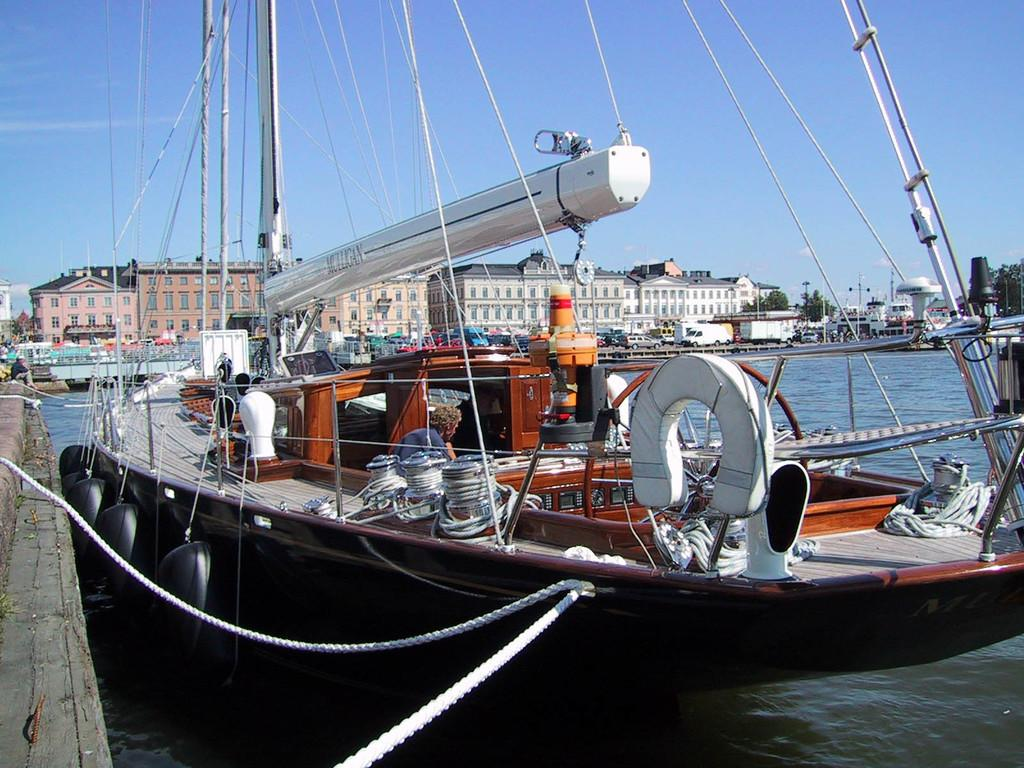What type of vehicles can be seen in the image? There are vehicles in the image, but the specific types are not mentioned. What structures are present in the image? There are buildings in the image. What natural elements can be seen in the image? There are trees in the image. What can be seen through the windows in the image? The windows in the image provide a view of the surroundings, but the specific view is not mentioned. How many people are visible in the image? There are people in the image, but the exact number is not mentioned. What are the poles used for in the image? The purpose of the poles in the image is not mentioned. What other objects can be seen in the image? There are other objects in the image, but their specific nature is not mentioned. What is visible in the background of the image? The sky is visible in the background of the image. Where is the bomb located in the image? There is no bomb present in the image. What type of quartz can be seen in the image? There is no quartz present in the image. What color is the rose in the image? There is no rose present in the image. 